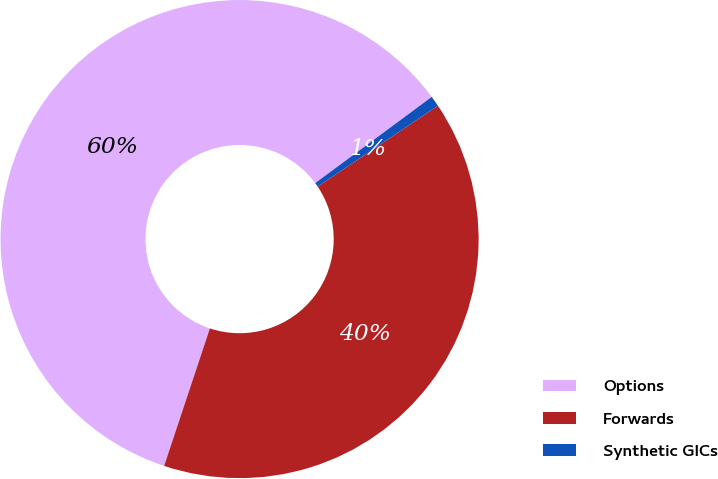Convert chart to OTSL. <chart><loc_0><loc_0><loc_500><loc_500><pie_chart><fcel>Options<fcel>Forwards<fcel>Synthetic GICs<nl><fcel>59.75%<fcel>39.53%<fcel>0.72%<nl></chart> 